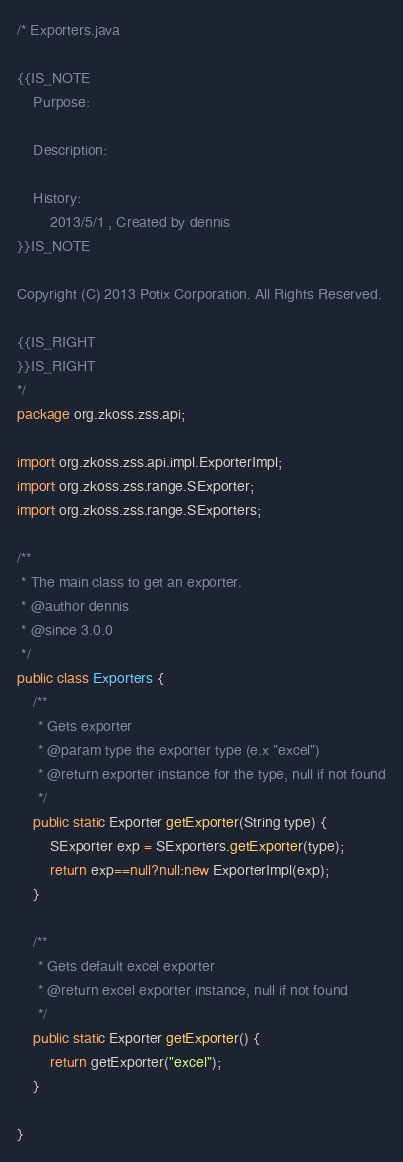Convert code to text. <code><loc_0><loc_0><loc_500><loc_500><_Java_>/* Exporters.java

{{IS_NOTE
	Purpose:
		
	Description:
		
	History:
		2013/5/1 , Created by dennis
}}IS_NOTE

Copyright (C) 2013 Potix Corporation. All Rights Reserved.

{{IS_RIGHT
}}IS_RIGHT
*/
package org.zkoss.zss.api;

import org.zkoss.zss.api.impl.ExporterImpl;
import org.zkoss.zss.range.SExporter;
import org.zkoss.zss.range.SExporters;

/**
 * The main class to get an exporter.
 * @author dennis
 * @since 3.0.0
 */
public class Exporters {
	/**
	 * Gets exporter
	 * @param type the exporter type (e.x "excel")
	 * @return exporter instance for the type, null if not found
	 */
	public static Exporter getExporter(String type) {
		SExporter exp = SExporters.getExporter(type);
		return exp==null?null:new ExporterImpl(exp);
	}
	
	/**
	 * Gets default excel exporter
	 * @return excel exporter instance, null if not found
	 */
	public static Exporter getExporter() {
		return getExporter("excel");
	}

}
</code> 